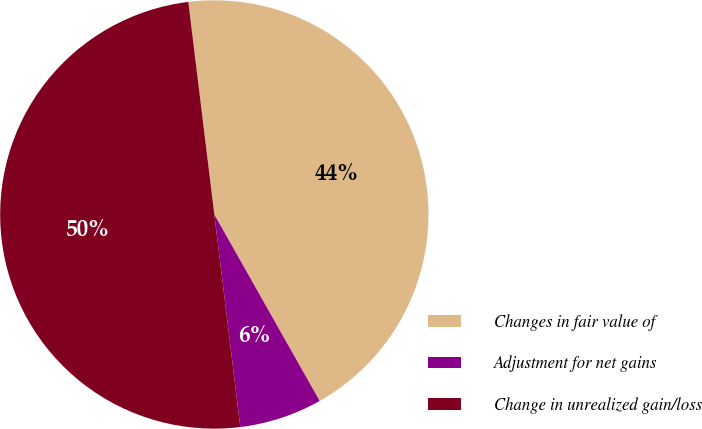<chart> <loc_0><loc_0><loc_500><loc_500><pie_chart><fcel>Changes in fair value of<fcel>Adjustment for net gains<fcel>Change in unrealized gain/loss<nl><fcel>43.75%<fcel>6.25%<fcel>50.0%<nl></chart> 